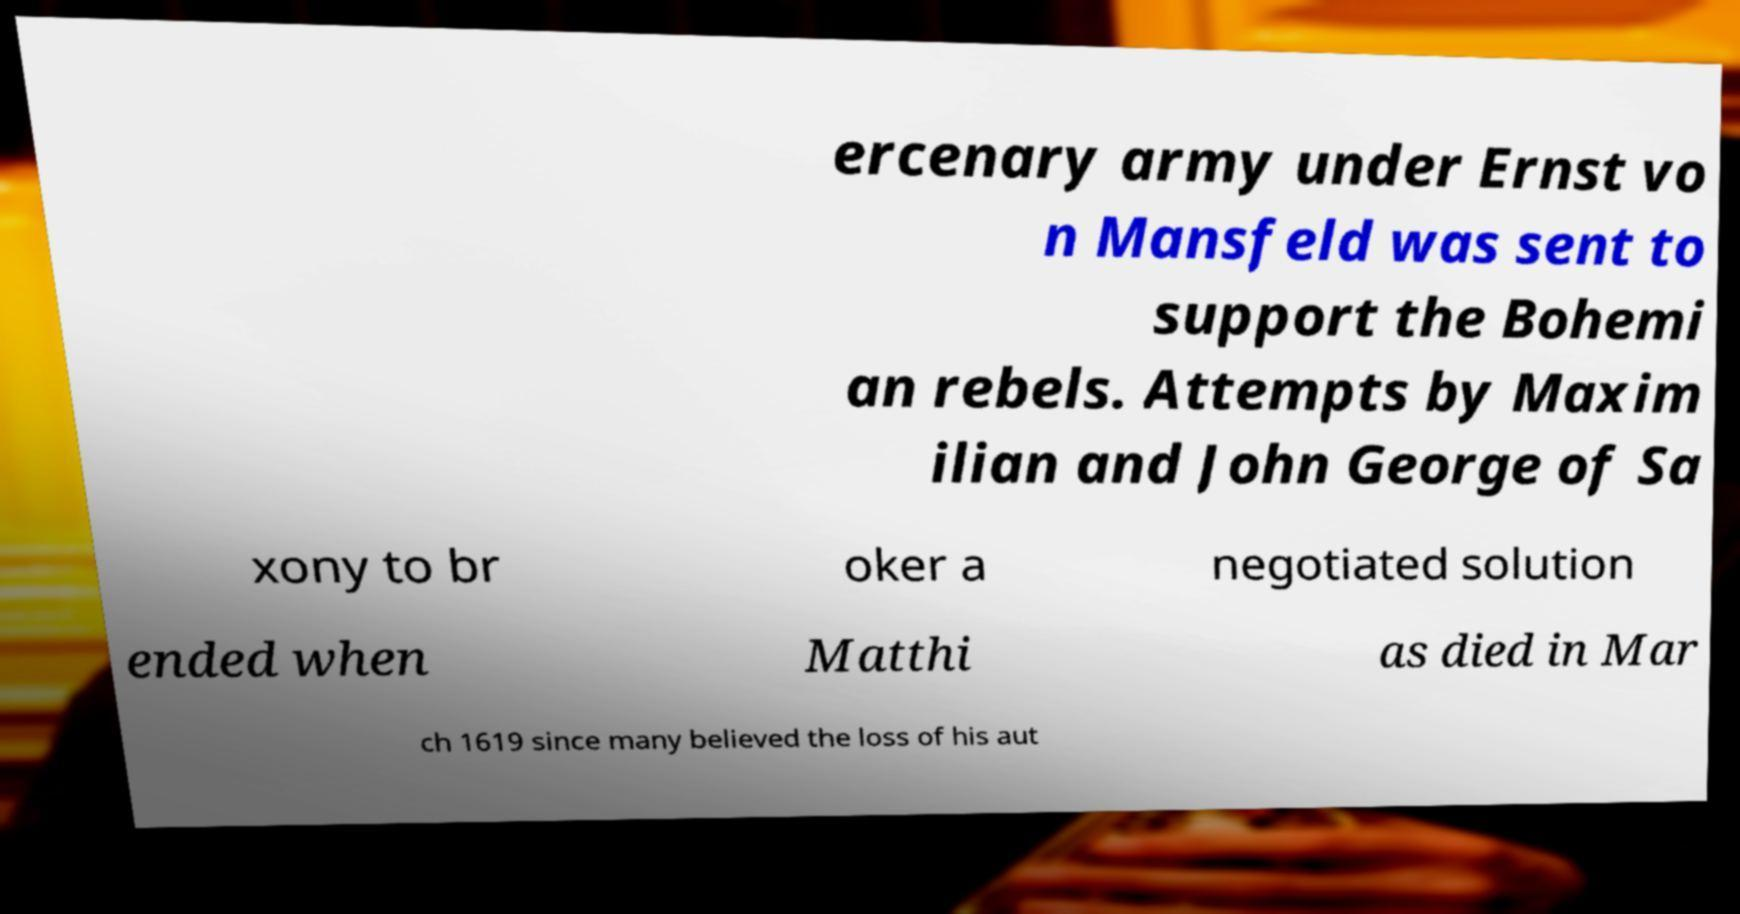Could you assist in decoding the text presented in this image and type it out clearly? ercenary army under Ernst vo n Mansfeld was sent to support the Bohemi an rebels. Attempts by Maxim ilian and John George of Sa xony to br oker a negotiated solution ended when Matthi as died in Mar ch 1619 since many believed the loss of his aut 